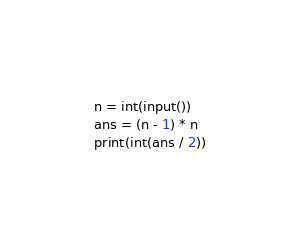<code> <loc_0><loc_0><loc_500><loc_500><_Python_>n = int(input())
ans = (n - 1) * n
print(int(ans / 2))</code> 